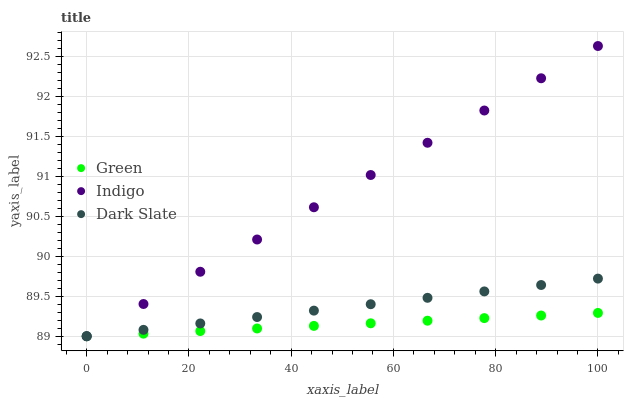Does Green have the minimum area under the curve?
Answer yes or no. Yes. Does Indigo have the maximum area under the curve?
Answer yes or no. Yes. Does Dark Slate have the minimum area under the curve?
Answer yes or no. No. Does Dark Slate have the maximum area under the curve?
Answer yes or no. No. Is Green the smoothest?
Answer yes or no. Yes. Is Indigo the roughest?
Answer yes or no. Yes. Is Dark Slate the smoothest?
Answer yes or no. No. Is Dark Slate the roughest?
Answer yes or no. No. Does Indigo have the lowest value?
Answer yes or no. Yes. Does Indigo have the highest value?
Answer yes or no. Yes. Does Dark Slate have the highest value?
Answer yes or no. No. Does Indigo intersect Green?
Answer yes or no. Yes. Is Indigo less than Green?
Answer yes or no. No. Is Indigo greater than Green?
Answer yes or no. No. 